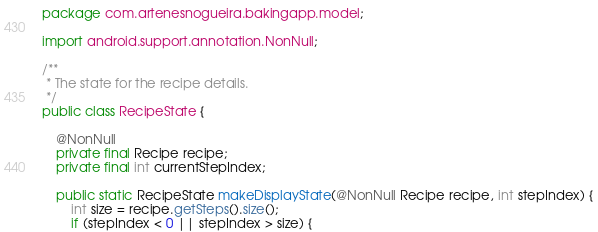Convert code to text. <code><loc_0><loc_0><loc_500><loc_500><_Java_>package com.artenesnogueira.bakingapp.model;

import android.support.annotation.NonNull;

/**
 * The state for the recipe details.
 */
public class RecipeState {

    @NonNull
    private final Recipe recipe;
    private final int currentStepIndex;

    public static RecipeState makeDisplayState(@NonNull Recipe recipe, int stepIndex) {
        int size = recipe.getSteps().size();
        if (stepIndex < 0 || stepIndex > size) {</code> 